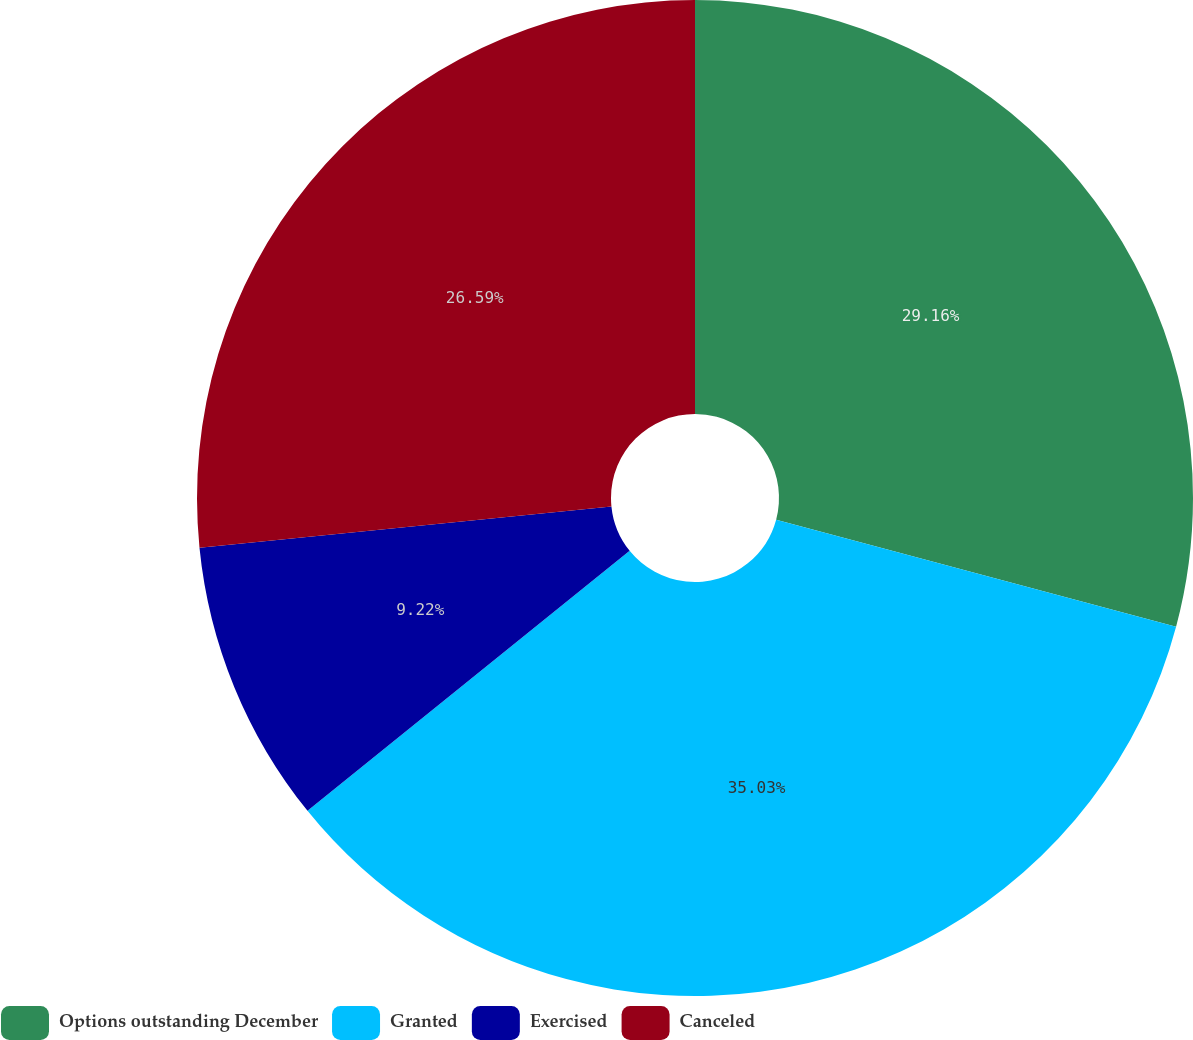Convert chart. <chart><loc_0><loc_0><loc_500><loc_500><pie_chart><fcel>Options outstanding December<fcel>Granted<fcel>Exercised<fcel>Canceled<nl><fcel>29.16%<fcel>35.03%<fcel>9.22%<fcel>26.59%<nl></chart> 